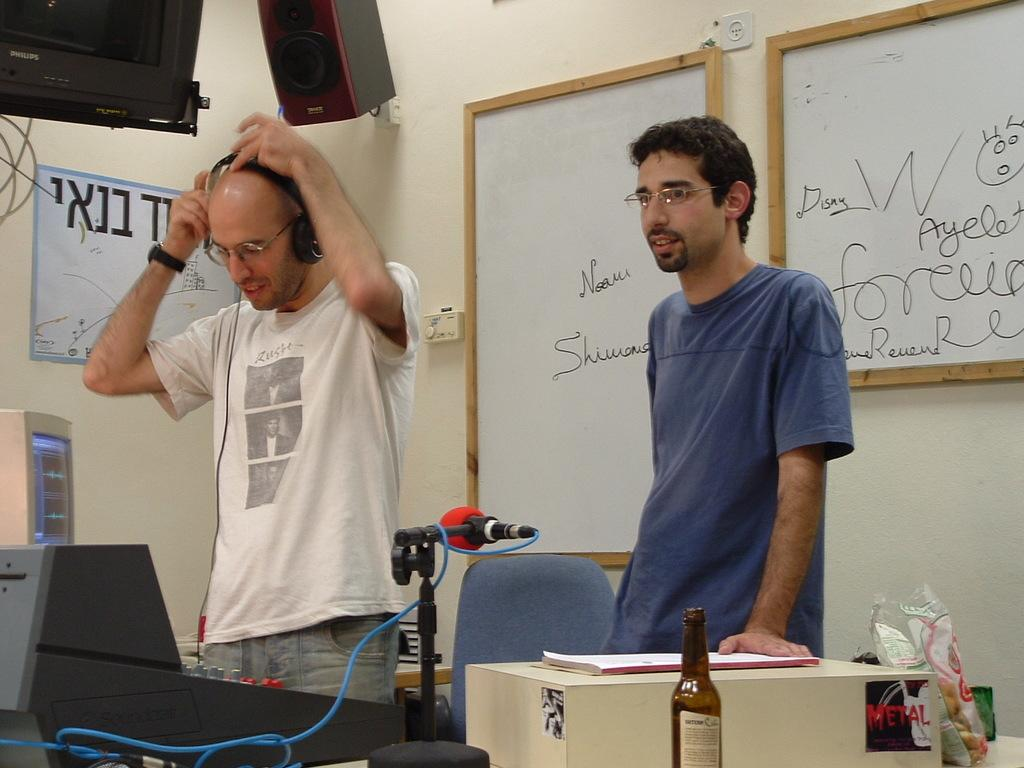<image>
Present a compact description of the photo's key features. the word W that is on a white board 